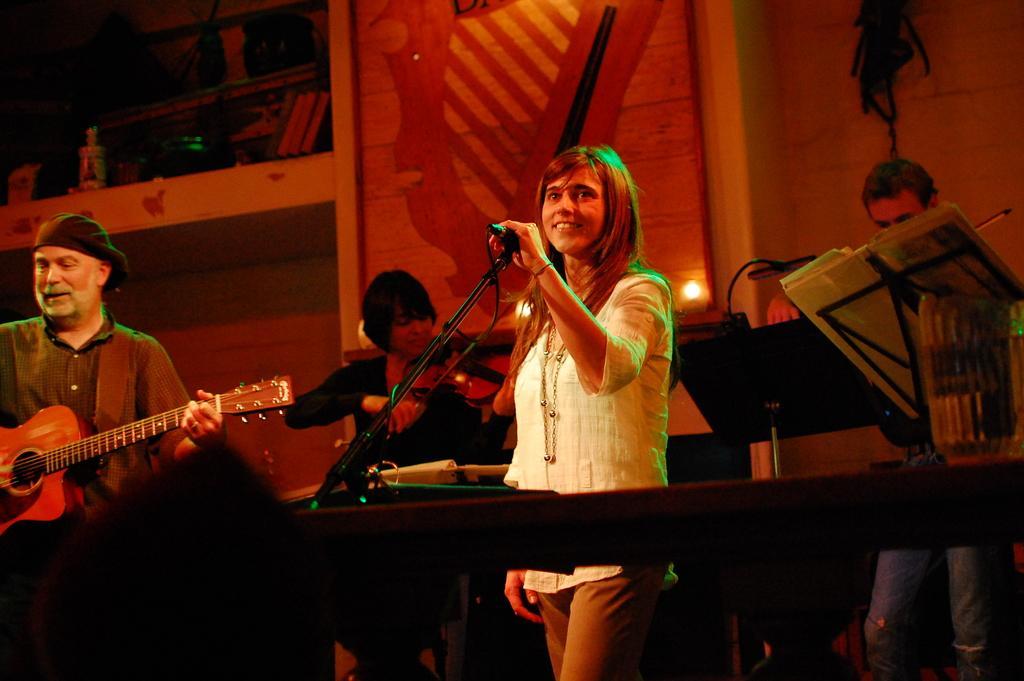Please provide a concise description of this image. As we can see in the image there is a wall and few people playing different types of musical instruments. 